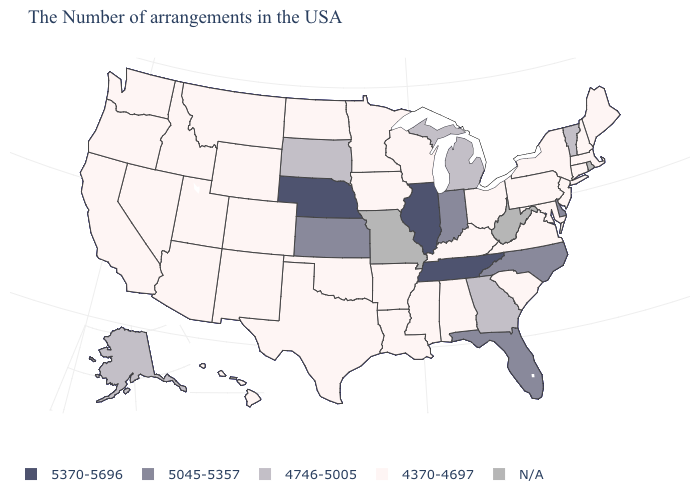Does Pennsylvania have the lowest value in the USA?
Quick response, please. Yes. Name the states that have a value in the range N/A?
Quick response, please. Rhode Island, West Virginia, Missouri. Which states have the lowest value in the USA?
Short answer required. Maine, Massachusetts, New Hampshire, Connecticut, New York, New Jersey, Maryland, Pennsylvania, Virginia, South Carolina, Ohio, Kentucky, Alabama, Wisconsin, Mississippi, Louisiana, Arkansas, Minnesota, Iowa, Oklahoma, Texas, North Dakota, Wyoming, Colorado, New Mexico, Utah, Montana, Arizona, Idaho, Nevada, California, Washington, Oregon, Hawaii. What is the value of Nevada?
Short answer required. 4370-4697. What is the value of Mississippi?
Quick response, please. 4370-4697. What is the lowest value in states that border Massachusetts?
Be succinct. 4370-4697. Name the states that have a value in the range 4746-5005?
Keep it brief. Vermont, Georgia, Michigan, South Dakota, Alaska. Does the map have missing data?
Give a very brief answer. Yes. Name the states that have a value in the range 5370-5696?
Write a very short answer. Tennessee, Illinois, Nebraska. Name the states that have a value in the range 4370-4697?
Give a very brief answer. Maine, Massachusetts, New Hampshire, Connecticut, New York, New Jersey, Maryland, Pennsylvania, Virginia, South Carolina, Ohio, Kentucky, Alabama, Wisconsin, Mississippi, Louisiana, Arkansas, Minnesota, Iowa, Oklahoma, Texas, North Dakota, Wyoming, Colorado, New Mexico, Utah, Montana, Arizona, Idaho, Nevada, California, Washington, Oregon, Hawaii. Which states have the lowest value in the USA?
Keep it brief. Maine, Massachusetts, New Hampshire, Connecticut, New York, New Jersey, Maryland, Pennsylvania, Virginia, South Carolina, Ohio, Kentucky, Alabama, Wisconsin, Mississippi, Louisiana, Arkansas, Minnesota, Iowa, Oklahoma, Texas, North Dakota, Wyoming, Colorado, New Mexico, Utah, Montana, Arizona, Idaho, Nevada, California, Washington, Oregon, Hawaii. Among the states that border Utah , which have the lowest value?
Answer briefly. Wyoming, Colorado, New Mexico, Arizona, Idaho, Nevada. Name the states that have a value in the range 4370-4697?
Give a very brief answer. Maine, Massachusetts, New Hampshire, Connecticut, New York, New Jersey, Maryland, Pennsylvania, Virginia, South Carolina, Ohio, Kentucky, Alabama, Wisconsin, Mississippi, Louisiana, Arkansas, Minnesota, Iowa, Oklahoma, Texas, North Dakota, Wyoming, Colorado, New Mexico, Utah, Montana, Arizona, Idaho, Nevada, California, Washington, Oregon, Hawaii. Which states have the lowest value in the USA?
Short answer required. Maine, Massachusetts, New Hampshire, Connecticut, New York, New Jersey, Maryland, Pennsylvania, Virginia, South Carolina, Ohio, Kentucky, Alabama, Wisconsin, Mississippi, Louisiana, Arkansas, Minnesota, Iowa, Oklahoma, Texas, North Dakota, Wyoming, Colorado, New Mexico, Utah, Montana, Arizona, Idaho, Nevada, California, Washington, Oregon, Hawaii. Is the legend a continuous bar?
Write a very short answer. No. 